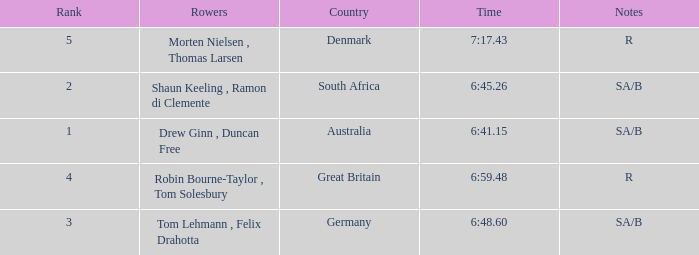What was the highest rank for rowers who represented Denmark? 5.0. 